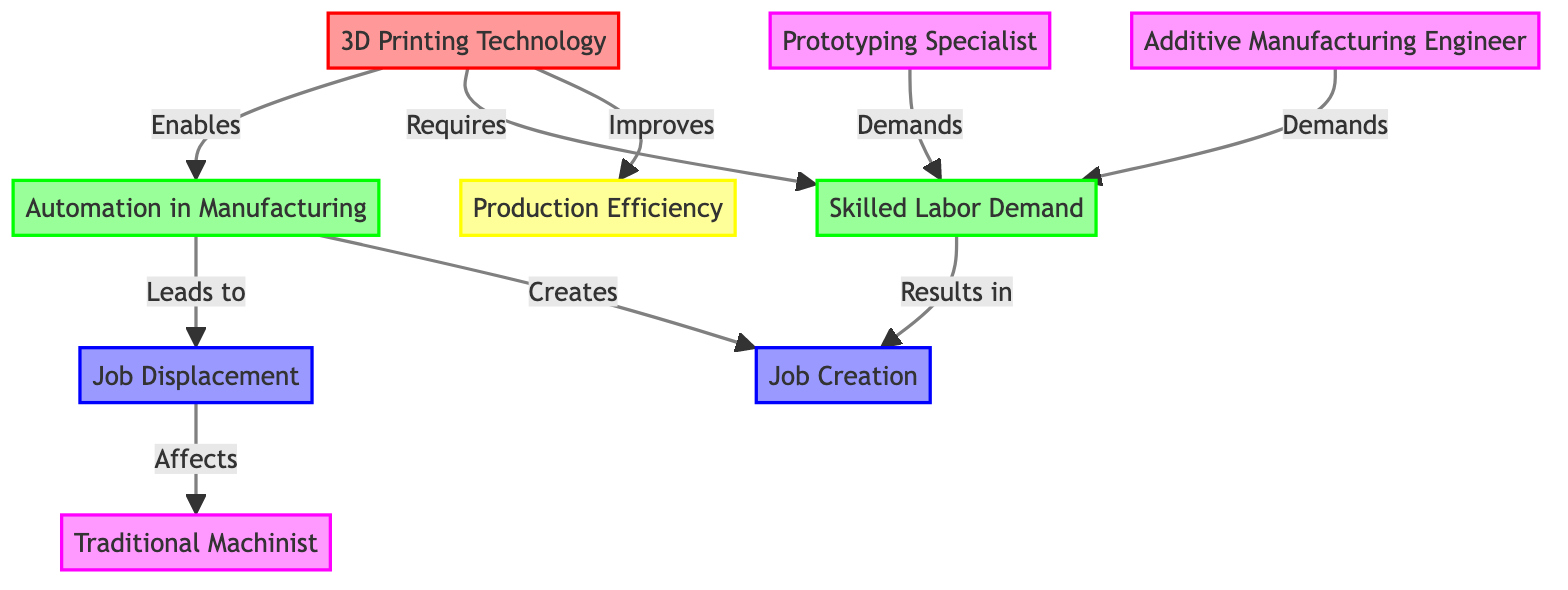What are the two outcomes of automation in manufacturing? The diagram shows that automation in manufacturing leads to both job displacement and job creation as indicated by the connections in the flowchart.
Answer: Job Displacement, Job Creation How many professional roles are indicated in the diagram? By counting the nodes representing professional roles, we find three distinct roles: Prototyping Specialist, Traditional Machinist, and Additive Manufacturing Engineer.
Answer: 3 What does 3D printing technology enable in manufacturing? The diagram specifies that 3D printing technology enables automation in manufacturing as shown by the directed edge connecting the two nodes.
Answer: Automation in Manufacturing Which area does 3D printing require? The diagram indicates that 3D printing requires skilled labor demand, as noted by the directed connection from 3D printing technology to skilled labor demand.
Answer: Skilled Labor Demand How does job displacement affect traditional machinists? The flowchart illustrates that job displacement directly affects traditional machinists, indicating a potential loss of employment opportunities for this profession.
Answer: Affects What is the impact of skilled labor demand in the context of 3D printing? The diagram illustrates that the demand for skilled labor results in job creation, demonstrating a positive outcome in response to the technological advancement of 3D printing.
Answer: Job Creation What improvement does 3D printing technology bring to manufacturing? The diagram indicates that 3D printing technology improves production efficiency, as shown by the labeled connection pointing from 3D printing to production efficiency.
Answer: Production Efficiency Which professions demand skilled labor? The flowchart specifies that both Prototyping Specialist and Additive Manufacturing Engineer demand skilled labor, as indicated by the connections from those professions to skilled labor demand.
Answer: Prototyping Specialist, Additive Manufacturing Engineer 